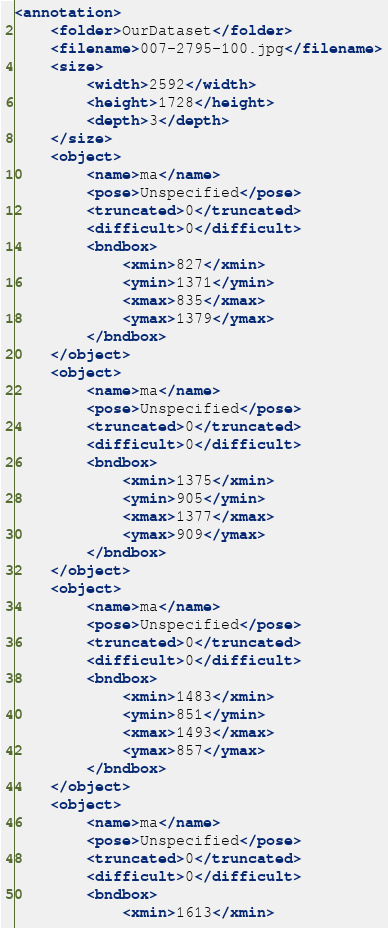<code> <loc_0><loc_0><loc_500><loc_500><_XML_><annotation>
    <folder>OurDataset</folder>
    <filename>007-2795-100.jpg</filename>
    <size>
        <width>2592</width>
        <height>1728</height>
        <depth>3</depth>
    </size>
    <object>
        <name>ma</name>
        <pose>Unspecified</pose>
        <truncated>0</truncated>
        <difficult>0</difficult>
        <bndbox>
            <xmin>827</xmin>
            <ymin>1371</ymin>
            <xmax>835</xmax>
            <ymax>1379</ymax>
        </bndbox>
    </object>
    <object>
        <name>ma</name>
        <pose>Unspecified</pose>
        <truncated>0</truncated>
        <difficult>0</difficult>
        <bndbox>
            <xmin>1375</xmin>
            <ymin>905</ymin>
            <xmax>1377</xmax>
            <ymax>909</ymax>
        </bndbox>
    </object>
    <object>
        <name>ma</name>
        <pose>Unspecified</pose>
        <truncated>0</truncated>
        <difficult>0</difficult>
        <bndbox>
            <xmin>1483</xmin>
            <ymin>851</ymin>
            <xmax>1493</xmax>
            <ymax>857</ymax>
        </bndbox>
    </object>
    <object>
        <name>ma</name>
        <pose>Unspecified</pose>
        <truncated>0</truncated>
        <difficult>0</difficult>
        <bndbox>
            <xmin>1613</xmin></code> 